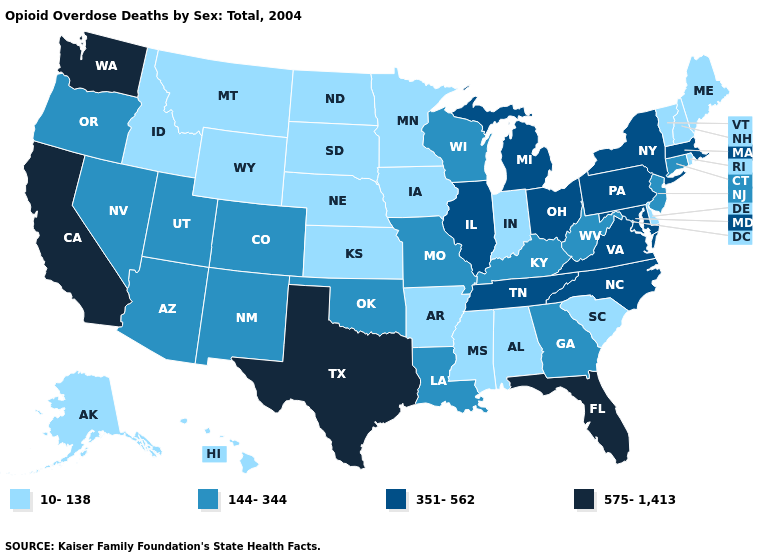Is the legend a continuous bar?
Concise answer only. No. Among the states that border Wisconsin , does Illinois have the highest value?
Answer briefly. Yes. Among the states that border Georgia , does Florida have the lowest value?
Be succinct. No. What is the value of Georgia?
Concise answer only. 144-344. Among the states that border North Carolina , does Virginia have the lowest value?
Write a very short answer. No. Does Washington have the highest value in the USA?
Answer briefly. Yes. Which states have the lowest value in the USA?
Be succinct. Alabama, Alaska, Arkansas, Delaware, Hawaii, Idaho, Indiana, Iowa, Kansas, Maine, Minnesota, Mississippi, Montana, Nebraska, New Hampshire, North Dakota, Rhode Island, South Carolina, South Dakota, Vermont, Wyoming. Does Delaware have the lowest value in the South?
Be succinct. Yes. Name the states that have a value in the range 351-562?
Concise answer only. Illinois, Maryland, Massachusetts, Michigan, New York, North Carolina, Ohio, Pennsylvania, Tennessee, Virginia. What is the value of Massachusetts?
Quick response, please. 351-562. Name the states that have a value in the range 144-344?
Keep it brief. Arizona, Colorado, Connecticut, Georgia, Kentucky, Louisiana, Missouri, Nevada, New Jersey, New Mexico, Oklahoma, Oregon, Utah, West Virginia, Wisconsin. Name the states that have a value in the range 144-344?
Quick response, please. Arizona, Colorado, Connecticut, Georgia, Kentucky, Louisiana, Missouri, Nevada, New Jersey, New Mexico, Oklahoma, Oregon, Utah, West Virginia, Wisconsin. What is the value of Virginia?
Concise answer only. 351-562. Does Rhode Island have the lowest value in the Northeast?
Answer briefly. Yes. What is the highest value in the West ?
Concise answer only. 575-1,413. 